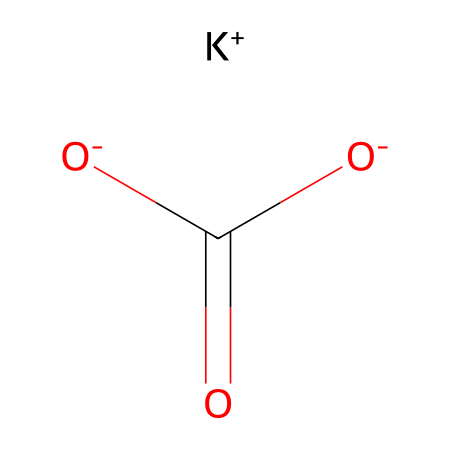how many carbon atoms are in potassium bicarbonate? The SMILES representation indicates there is one 'C' in the structure, which is part of the bicarbonate ion.
Answer: 1 what is the overall charge of potassium bicarbonate? The potassium ion (K+) has a +1 charge and there are two negative charges from the bicarbonate ion ([O-]C(=O)[O-]), giving an overall charge of 0.
Answer: 0 what type of compound is potassium bicarbonate? The presence of potassium ions and bicarbonate anions indicates it is a salt.
Answer: salt which ion is positively charged in potassium bicarbonate? The potassium ion is noted as K+, which indicates it carries a positive charge.
Answer: potassium how does potassium bicarbonate function in sports drinks? It acts as an electrolyte, helping to maintain hydration and electrolyte balance which is crucial during physical activities.
Answer: electrolyte what is the role of bicarbonate in buffering? Bicarbonate helps to maintain pH levels in the blood and reduces acidity.
Answer: buffering which components are responsible for its solubility in water? Both the potassium ion (K+) and the bicarbonate ion ([O-]C(=O)[O-]) are highly soluble in water due to their ionic nature.
Answer: potassium and bicarbonate 